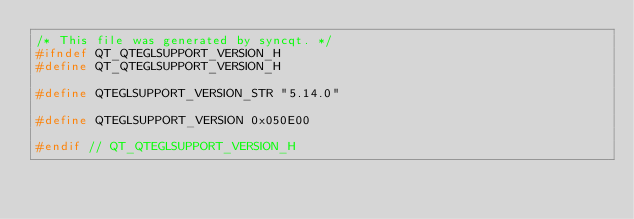Convert code to text. <code><loc_0><loc_0><loc_500><loc_500><_C_>/* This file was generated by syncqt. */
#ifndef QT_QTEGLSUPPORT_VERSION_H
#define QT_QTEGLSUPPORT_VERSION_H

#define QTEGLSUPPORT_VERSION_STR "5.14.0"

#define QTEGLSUPPORT_VERSION 0x050E00

#endif // QT_QTEGLSUPPORT_VERSION_H
</code> 